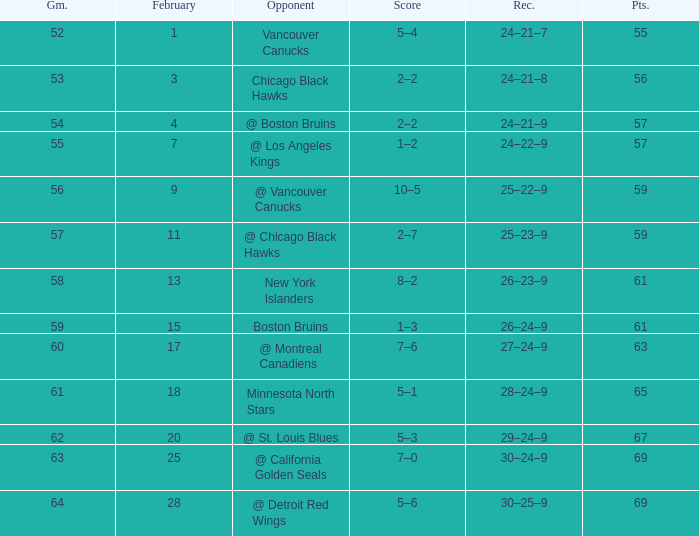Which opponent has a game larger than 61, february smaller than 28, and fewer points than 69? @ St. Louis Blues. 